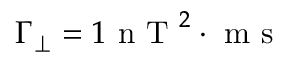<formula> <loc_0><loc_0><loc_500><loc_500>\Gamma _ { \perp } = 1 n T ^ { 2 } \cdot m s</formula> 